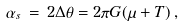<formula> <loc_0><loc_0><loc_500><loc_500>\alpha _ { s } \, = \, 2 \Delta \theta = 2 \pi G ( \mu + T ) \, ,</formula> 